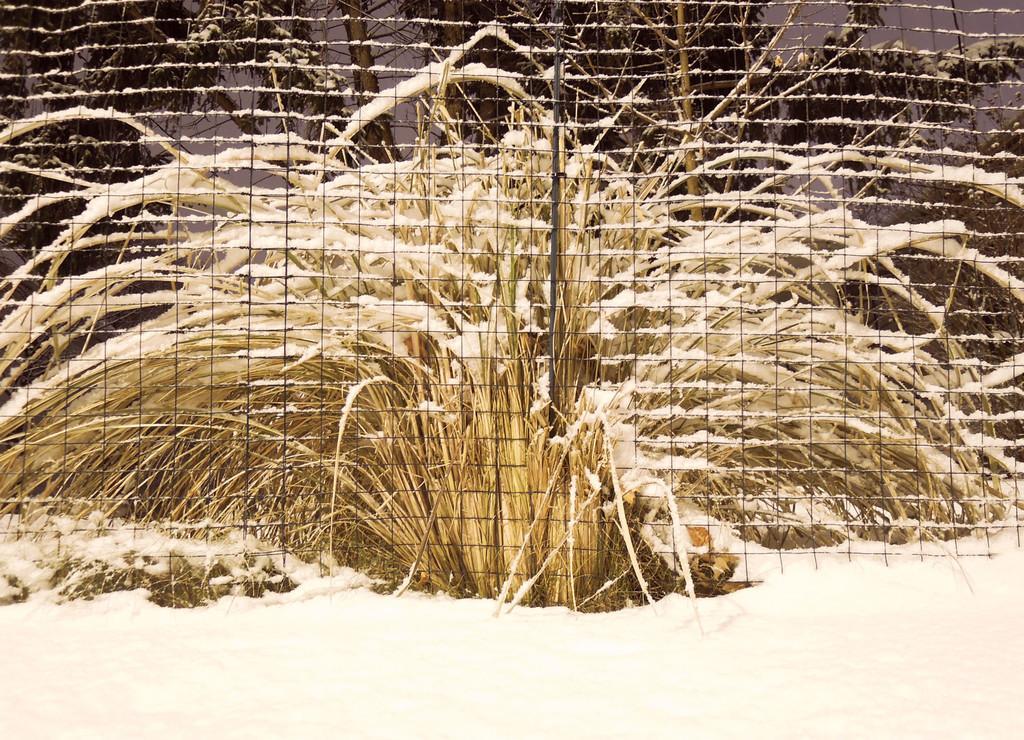Can you describe this image briefly? In this image there is grass in the middle. In front of the grass there is a metal fence. On the grass there is snow. 